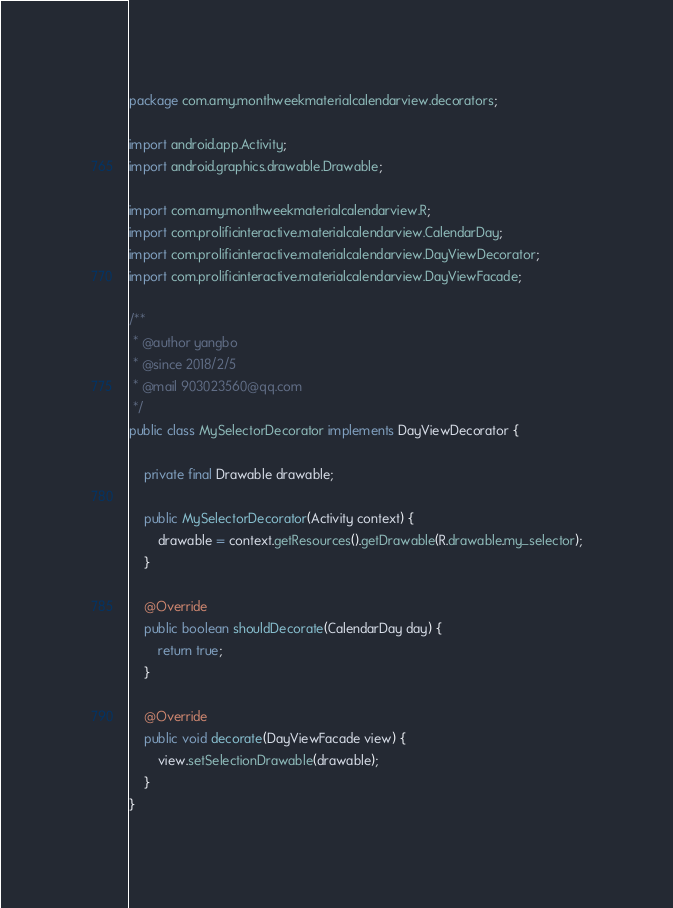<code> <loc_0><loc_0><loc_500><loc_500><_Java_>package com.amy.monthweekmaterialcalendarview.decorators;

import android.app.Activity;
import android.graphics.drawable.Drawable;

import com.amy.monthweekmaterialcalendarview.R;
import com.prolificinteractive.materialcalendarview.CalendarDay;
import com.prolificinteractive.materialcalendarview.DayViewDecorator;
import com.prolificinteractive.materialcalendarview.DayViewFacade;

/**
 * @author yangbo
 * @since 2018/2/5
 * @mail 903023560@qq.com
 */
public class MySelectorDecorator implements DayViewDecorator {

    private final Drawable drawable;

    public MySelectorDecorator(Activity context) {
        drawable = context.getResources().getDrawable(R.drawable.my_selector);
    }

    @Override
    public boolean shouldDecorate(CalendarDay day) {
        return true;
    }

    @Override
    public void decorate(DayViewFacade view) {
        view.setSelectionDrawable(drawable);
    }
}
</code> 